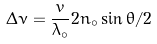Convert formula to latex. <formula><loc_0><loc_0><loc_500><loc_500>\Delta \nu = \frac { v } { \lambda _ { \circ } } 2 n _ { \circ } \sin { \theta / 2 }</formula> 